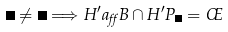<formula> <loc_0><loc_0><loc_500><loc_500>\Theta \ne \Psi \Longrightarrow H ^ { \prime } a _ { \alpha } B \cap H ^ { \prime } P _ { \Theta } = \phi</formula> 